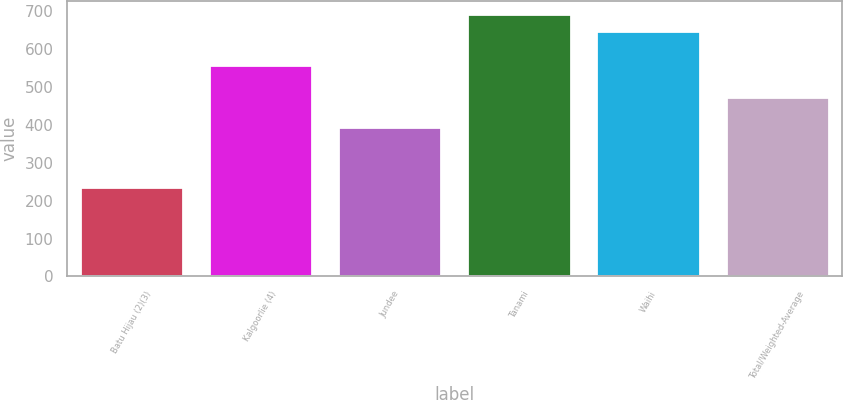Convert chart to OTSL. <chart><loc_0><loc_0><loc_500><loc_500><bar_chart><fcel>Batu Hijau (2)(3)<fcel>Kalgoorlie (4)<fcel>Jundee<fcel>Tanami<fcel>Waihi<fcel>Total/Weighted-Average<nl><fcel>237<fcel>558<fcel>393<fcel>692.2<fcel>647<fcel>474<nl></chart> 